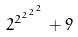<formula> <loc_0><loc_0><loc_500><loc_500>2 ^ { 2 ^ { 2 ^ { 2 ^ { 2 } } } } + 9</formula> 